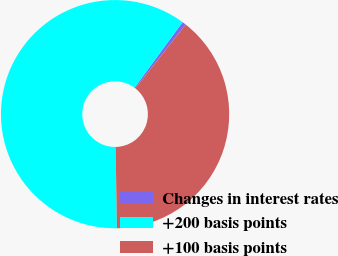Convert chart to OTSL. <chart><loc_0><loc_0><loc_500><loc_500><pie_chart><fcel>Changes in interest rates<fcel>+200 basis points<fcel>+100 basis points<nl><fcel>0.54%<fcel>60.34%<fcel>39.13%<nl></chart> 